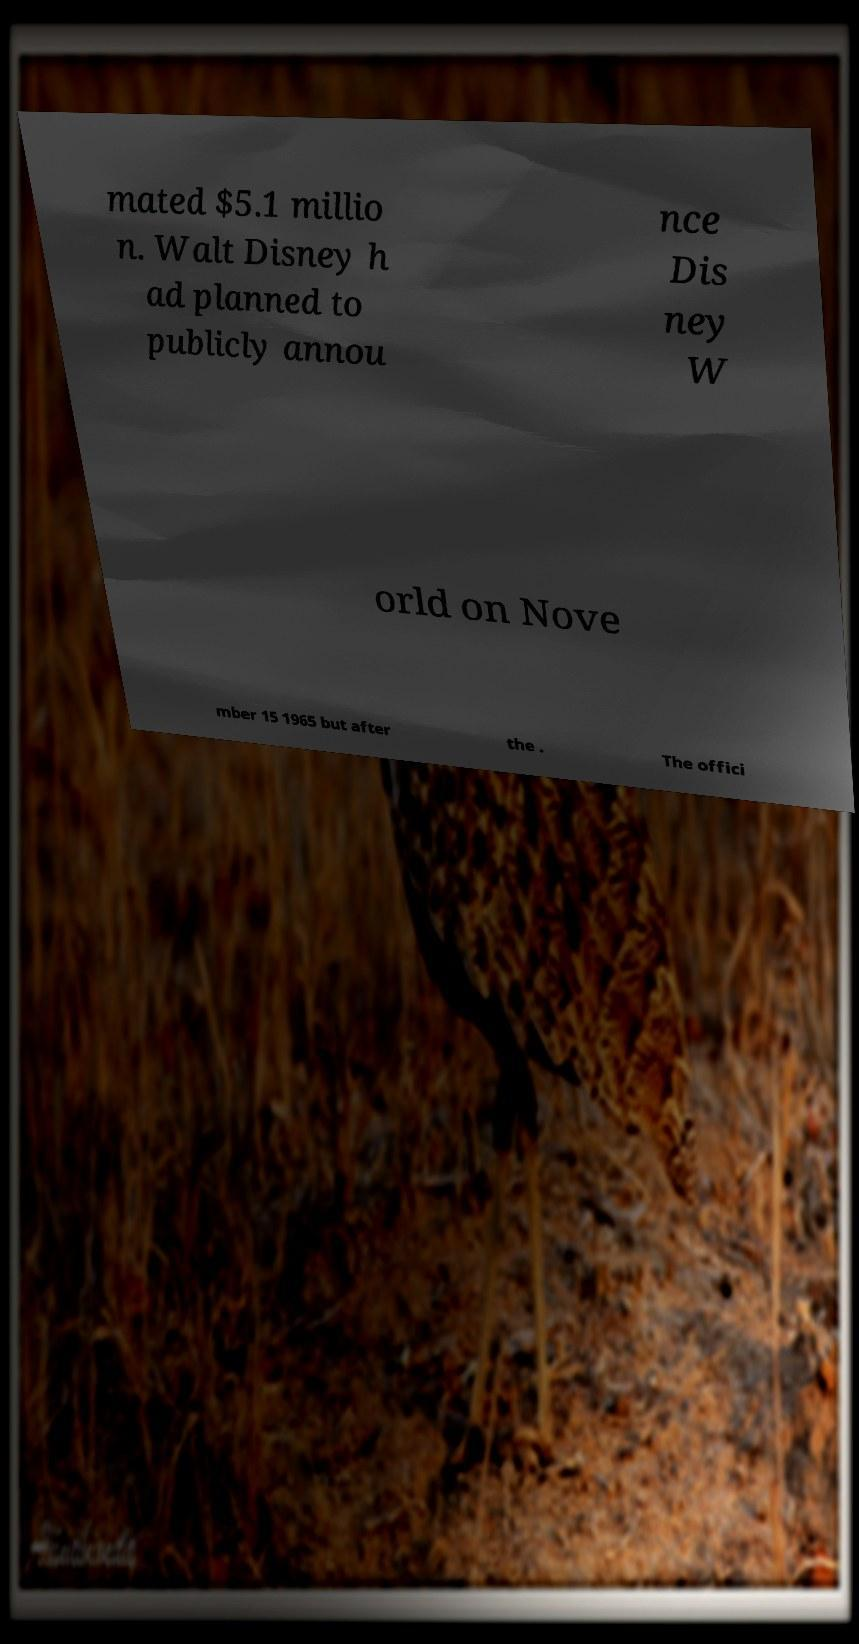I need the written content from this picture converted into text. Can you do that? mated $5.1 millio n. Walt Disney h ad planned to publicly annou nce Dis ney W orld on Nove mber 15 1965 but after the . The offici 